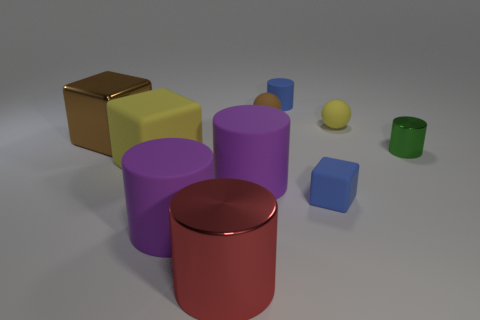Subtract all small blue rubber cylinders. How many cylinders are left? 4 Subtract all cubes. How many objects are left? 7 Subtract 1 cylinders. How many cylinders are left? 4 Subtract all brown blocks. How many brown cylinders are left? 0 Subtract all small yellow rubber spheres. Subtract all brown cubes. How many objects are left? 8 Add 1 yellow matte balls. How many yellow matte balls are left? 2 Add 9 large cyan rubber objects. How many large cyan rubber objects exist? 9 Subtract all green cylinders. How many cylinders are left? 4 Subtract 0 green spheres. How many objects are left? 10 Subtract all purple spheres. Subtract all gray cylinders. How many spheres are left? 2 